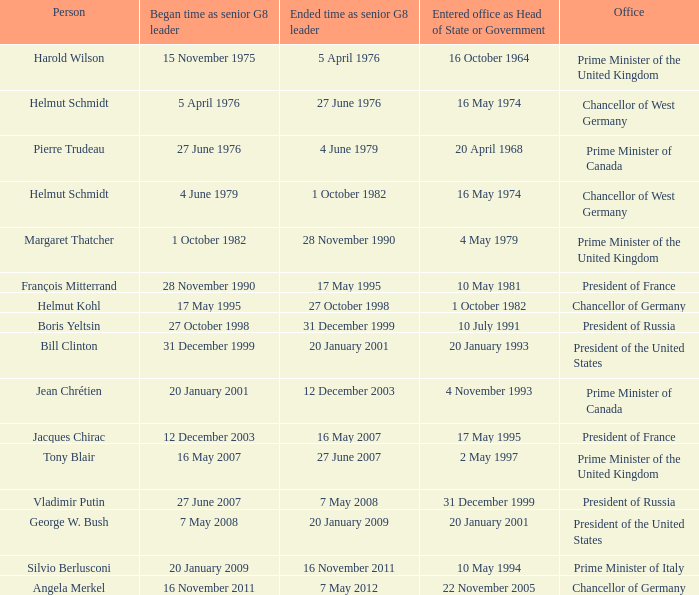Would you be able to parse every entry in this table? {'header': ['Person', 'Began time as senior G8 leader', 'Ended time as senior G8 leader', 'Entered office as Head of State or Government', 'Office'], 'rows': [['Harold Wilson', '15 November 1975', '5 April 1976', '16 October 1964', 'Prime Minister of the United Kingdom'], ['Helmut Schmidt', '5 April 1976', '27 June 1976', '16 May 1974', 'Chancellor of West Germany'], ['Pierre Trudeau', '27 June 1976', '4 June 1979', '20 April 1968', 'Prime Minister of Canada'], ['Helmut Schmidt', '4 June 1979', '1 October 1982', '16 May 1974', 'Chancellor of West Germany'], ['Margaret Thatcher', '1 October 1982', '28 November 1990', '4 May 1979', 'Prime Minister of the United Kingdom'], ['François Mitterrand', '28 November 1990', '17 May 1995', '10 May 1981', 'President of France'], ['Helmut Kohl', '17 May 1995', '27 October 1998', '1 October 1982', 'Chancellor of Germany'], ['Boris Yeltsin', '27 October 1998', '31 December 1999', '10 July 1991', 'President of Russia'], ['Bill Clinton', '31 December 1999', '20 January 2001', '20 January 1993', 'President of the United States'], ['Jean Chrétien', '20 January 2001', '12 December 2003', '4 November 1993', 'Prime Minister of Canada'], ['Jacques Chirac', '12 December 2003', '16 May 2007', '17 May 1995', 'President of France'], ['Tony Blair', '16 May 2007', '27 June 2007', '2 May 1997', 'Prime Minister of the United Kingdom'], ['Vladimir Putin', '27 June 2007', '7 May 2008', '31 December 1999', 'President of Russia'], ['George W. Bush', '7 May 2008', '20 January 2009', '20 January 2001', 'President of the United States'], ['Silvio Berlusconi', '20 January 2009', '16 November 2011', '10 May 1994', 'Prime Minister of Italy'], ['Angela Merkel', '16 November 2011', '7 May 2012', '22 November 2005', 'Chancellor of Germany']]} When did the Prime Minister of Italy take office? 10 May 1994. 